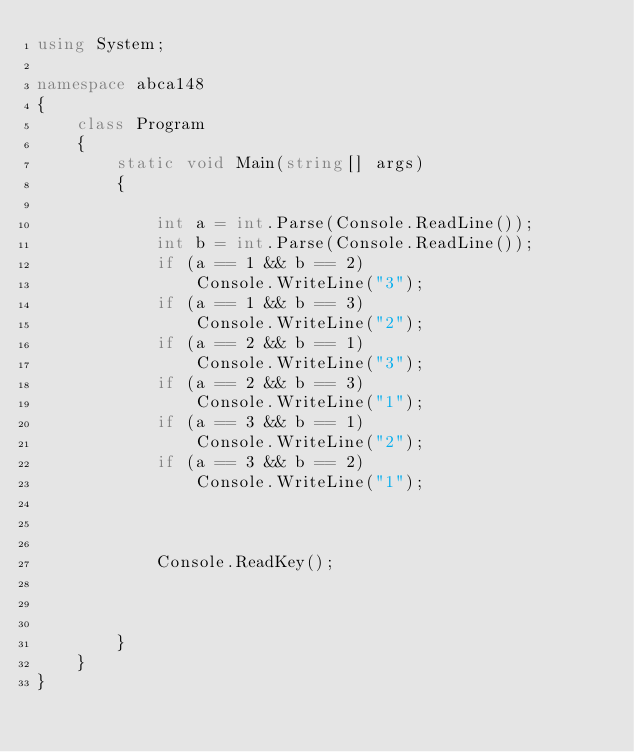<code> <loc_0><loc_0><loc_500><loc_500><_C#_>using System;

namespace abca148
{
    class Program
    {
        static void Main(string[] args)
        {
       
            int a = int.Parse(Console.ReadLine());
            int b = int.Parse(Console.ReadLine());
            if (a == 1 && b == 2)
                Console.WriteLine("3");
            if (a == 1 && b == 3)
                Console.WriteLine("2");
            if (a == 2 && b == 1)
                Console.WriteLine("3");
            if (a == 2 && b == 3)
                Console.WriteLine("1");
            if (a == 3 && b == 1)
                Console.WriteLine("2");
            if (a == 3 && b == 2)
                Console.WriteLine("1");
           


            Console.ReadKey();
 


        }
    }
}
</code> 